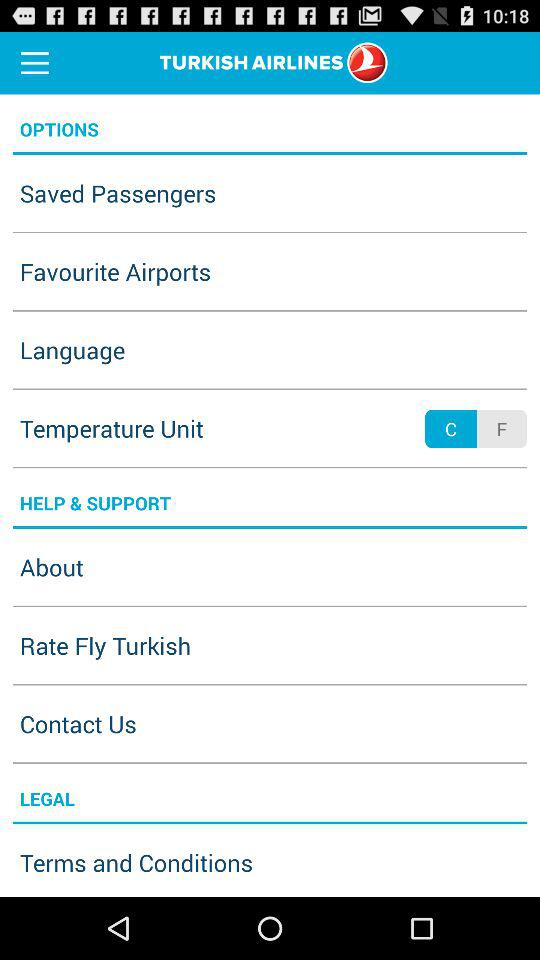What is the selected temperature unit? The temperature unit is C. 